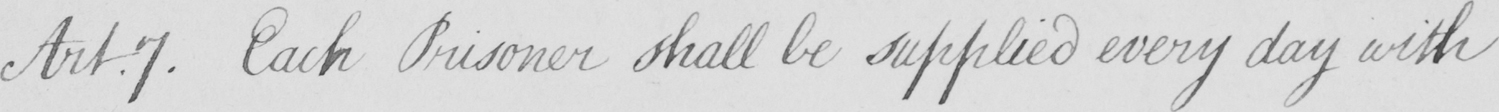Please provide the text content of this handwritten line. Art.7 . Each Prisoner shall be supplied every day with 